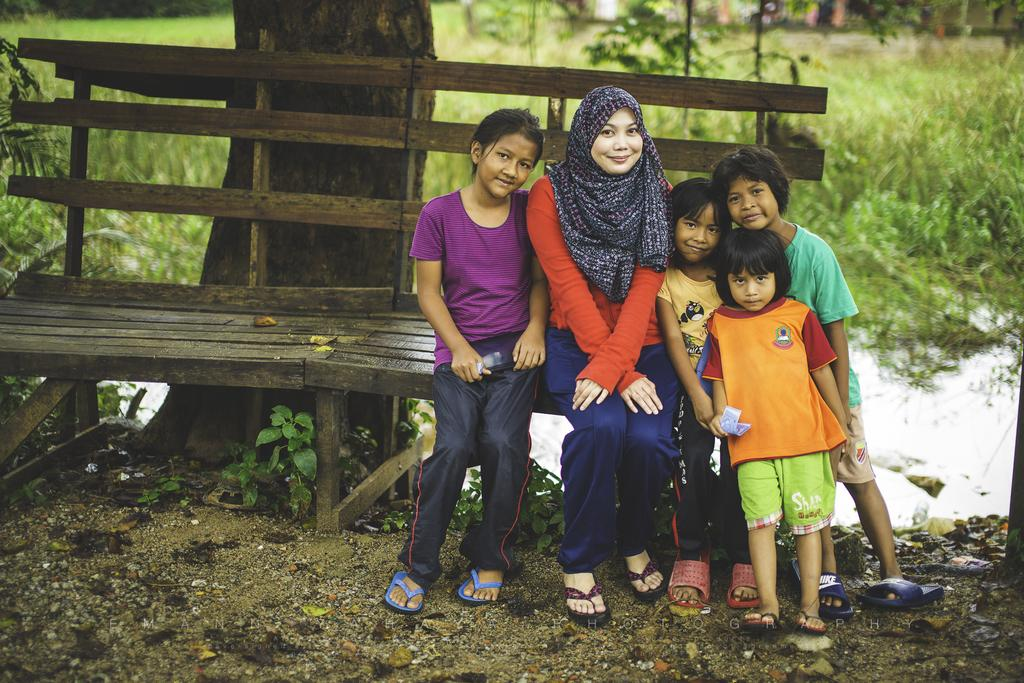How many people are in the image? There are people in the image, but the exact number is not specified. What are some of the people doing in the image? Some people are sitting on a bench, while others are standing. What type of vegetation can be seen in the image? There are plants, trees, and grass visible in the image. What else can be seen in the image besides people and vegetation? There is water visible in the image. Are the brothers in the image discussing their agreement about the wren? There is no mention of brothers, an agreement, or a wren in the image or the provided facts. 